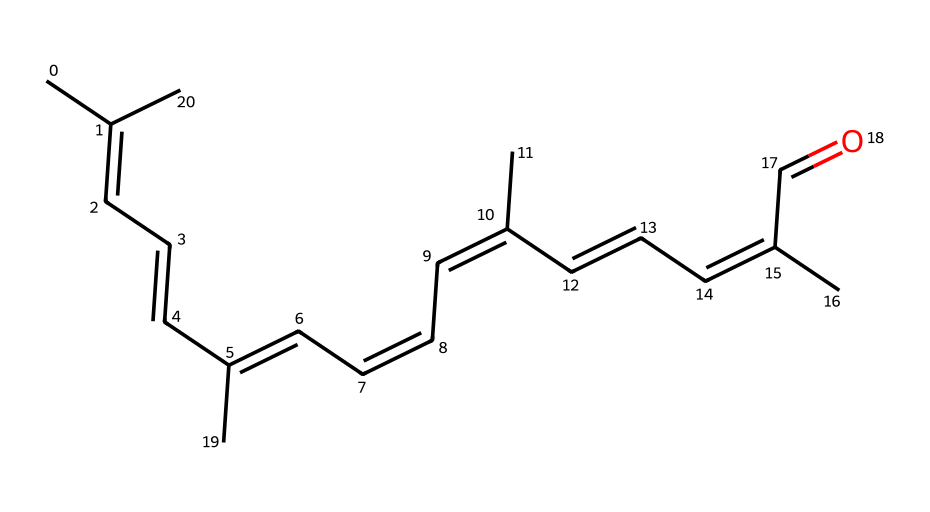How many carbon atoms are in the chemical structure? The chemical structure can be analyzed by counting the number of carbon symbols (C) in the SMILES representation, which indicates the number of carbon atoms present. In this case, there are 40 carbon symbols.
Answer: forty What is the degree of saturation in this chemical structure? The degree of saturation can be determined by analyzing the number of double bonds present in the molecule. Each double bond reduces the saturation by one compared to a saturated compound. In this structure, there are 9 double bonds, which indicates a high degree of unsaturation.
Answer: nine Is this chemical a saturated or unsaturated compound? By examining the presence of double bonds in the structure, we can deduce that the compound is unsaturated due to multiple C=C (double bonds) present.
Answer: unsaturated Which geometric isomer is associated with cis-retinal? The configuration of the double bonds in the molecule, specifically the orientation of the substituents, can define the isomer. In cis-retinal, the two highest priority substituents on one side of a double bond are on the same side, indicating it's a cis isomer.
Answer: cis What specific type of isomerism does cis-retinal exhibit? By identifying the key feature of the chemical, we recognize that cis-retinal exemplifies geometric isomerism, a type involving different spatial arrangements around the C=C bonds.
Answer: geometric How many double bonds are present in this molecule? The total number of double bonds can be counted by analyzing the structure for each occurrence of '=' in the SMILES notation. In this case, there are 9 double bonds.
Answer: nine What is the functional group at the end of the carbon chain? By looking at the end of the molecule, we identify that there is a carbonyl group (C=O) present, indicating that this functional group is an aldehyde.
Answer: aldehyde 